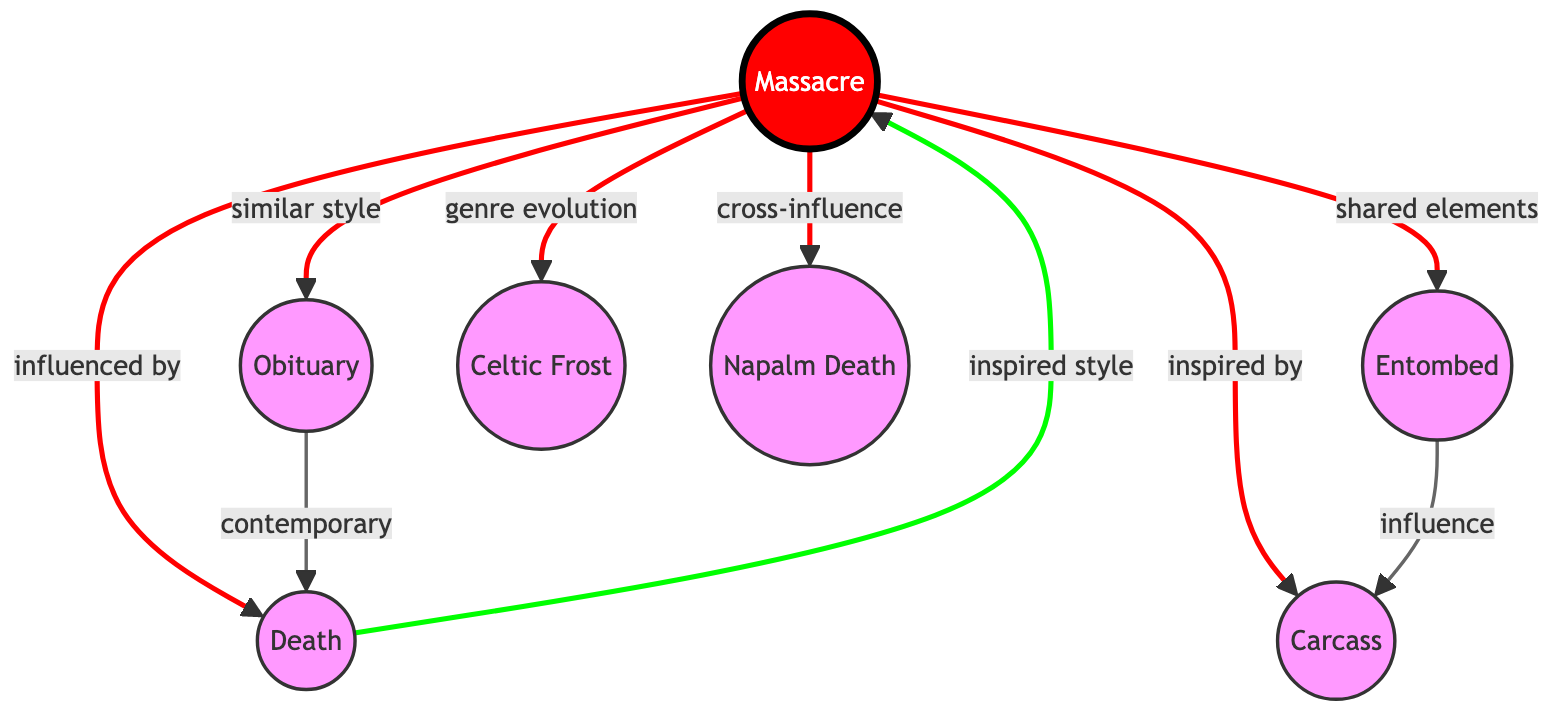What is the total number of nodes in the diagram? The nodes are Massacre, Death, Obituary, Entombed, Carcass, Celtic Frost, and Napalm Death. Counting these gives a total of 7 distinct nodes.
Answer: 7 What is the relationship between Massacre and Obituary? The diagram indicates that there is a direct connection from Massacre to Obituary labeled "similar style," which details the nature of their relationship.
Answer: similar style Which band influenced Massacre directly? Looking at the directed edges, there is a connection from Death to Massacre labeled "inspired style," indicating that Death has influenced Massacre.
Answer: Death How many edges are directed from Massacre? A quick count of the directed edges originating from Massacre shows there are six directions towards Death, Obituary, Entombed, Carcass, Celtic Frost, and Napalm Death, totaling 6 edges.
Answer: 6 What is the connection between Entombed and Carcass? The directed edge from Entombed to Carcass is labeled "influence," which specifies the nature of their connection within the death metal genre landscape.
Answer: influence Who are the contemporary bands along with Death? In the diagram, it shows that Obituary also has a directed edge towards Death, labeled "contemporary," indicating that Obituary is contemporary with Death.
Answer: Obituary Identify the band that has a relationship with Massacre categorized as "cross-influence." The directed edge from Massacre to Napalm Death is labeled "cross-influence," which identifies the specific type of relationship between the two bands.
Answer: Napalm Death Which band is noted for genre evolution in relation to Massacre? The diagram has an edge pointing from Massacre to Celtic Frost with the label "genre evolution," indicating Celtic Frost's influence on the progression of Massacre's style.
Answer: Celtic Frost How many bands are inspired by Death? The diagram shows that Massacre is inspired by Death, but there are no additional edges pointing from Death to any other bands. Therefore, only Massacre is directly indicated as inspired by Death.
Answer: 1 